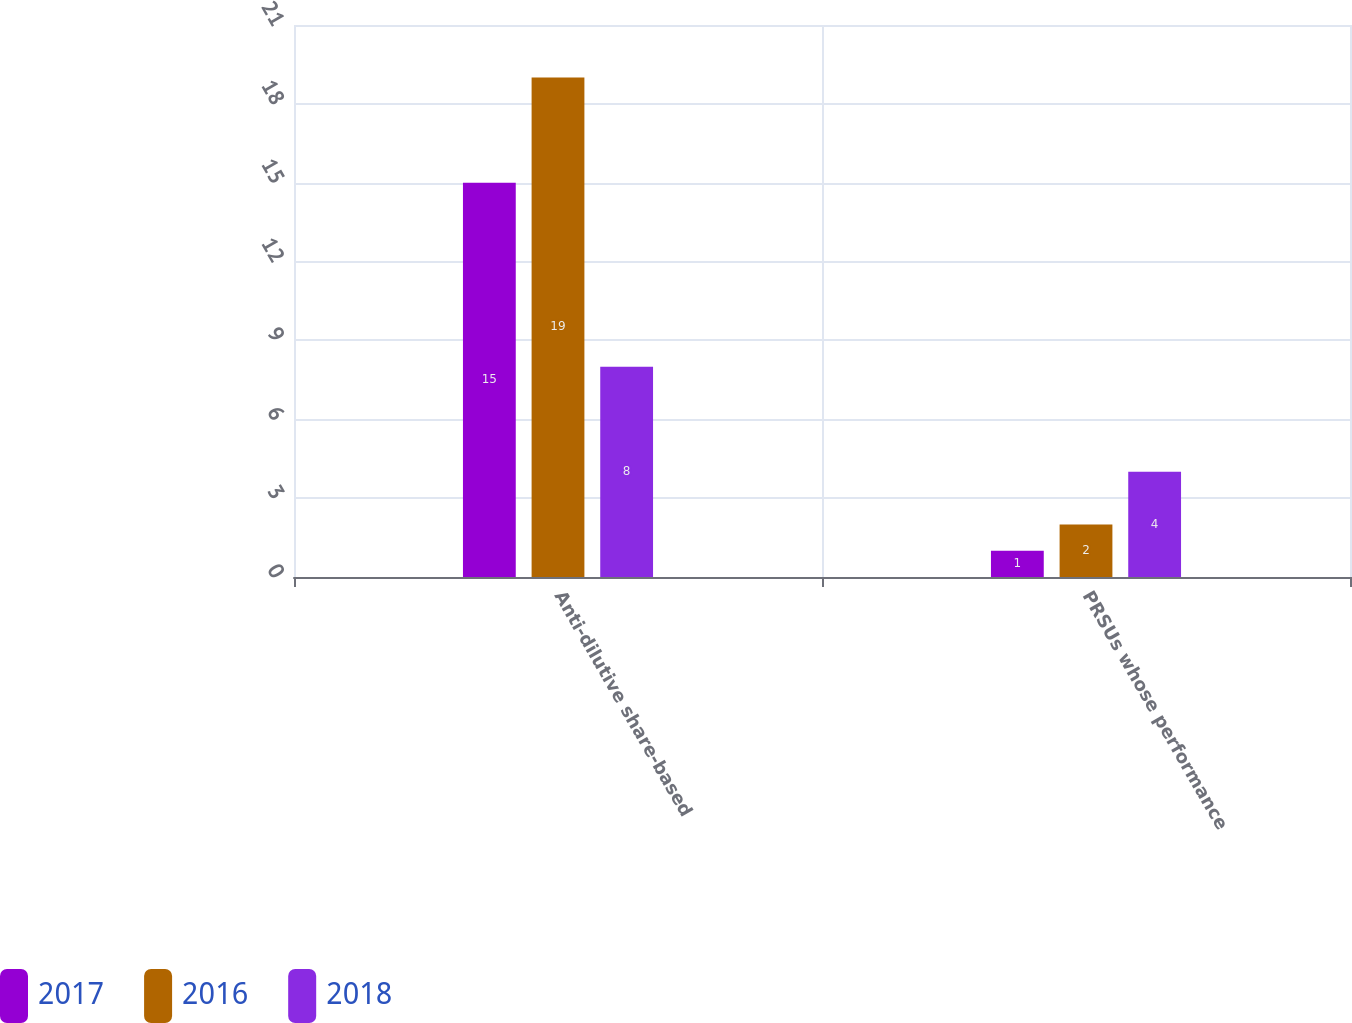<chart> <loc_0><loc_0><loc_500><loc_500><stacked_bar_chart><ecel><fcel>Anti-dilutive share-based<fcel>PRSUs whose performance<nl><fcel>2017<fcel>15<fcel>1<nl><fcel>2016<fcel>19<fcel>2<nl><fcel>2018<fcel>8<fcel>4<nl></chart> 